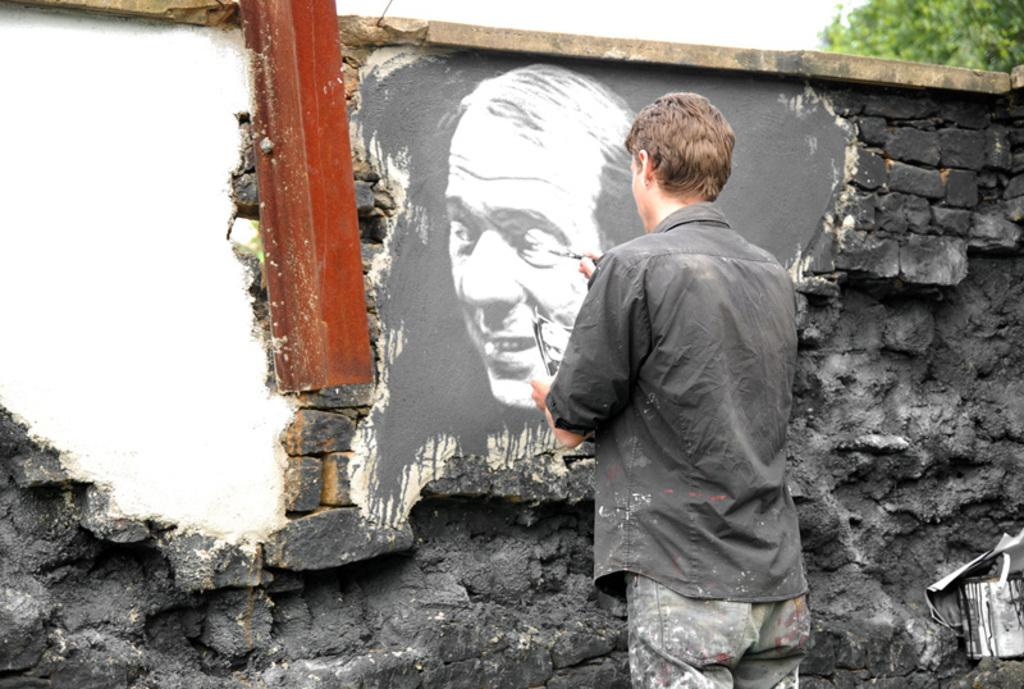What is the man in the image doing? The man is painting on a wall. Can you describe the location of the tree in the image? The tree is in the right side top corner of the image. What type of cork can be seen in the image? There is no cork present in the image. How does the man maintain a quiet environment while painting in the image? The image does not provide information about the noise level or the man's actions to maintain a quiet environment. 